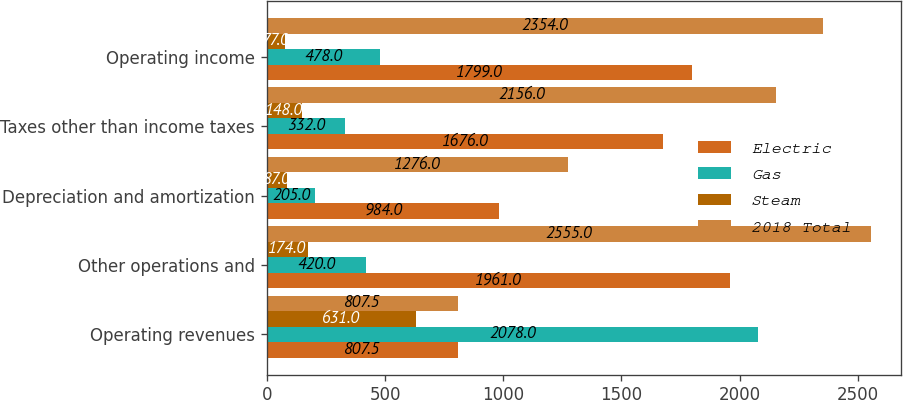Convert chart. <chart><loc_0><loc_0><loc_500><loc_500><stacked_bar_chart><ecel><fcel>Operating revenues<fcel>Other operations and<fcel>Depreciation and amortization<fcel>Taxes other than income taxes<fcel>Operating income<nl><fcel>Electric<fcel>807.5<fcel>1961<fcel>984<fcel>1676<fcel>1799<nl><fcel>Gas<fcel>2078<fcel>420<fcel>205<fcel>332<fcel>478<nl><fcel>Steam<fcel>631<fcel>174<fcel>87<fcel>148<fcel>77<nl><fcel>2018 Total<fcel>807.5<fcel>2555<fcel>1276<fcel>2156<fcel>2354<nl></chart> 